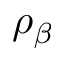Convert formula to latex. <formula><loc_0><loc_0><loc_500><loc_500>\rho _ { \beta }</formula> 